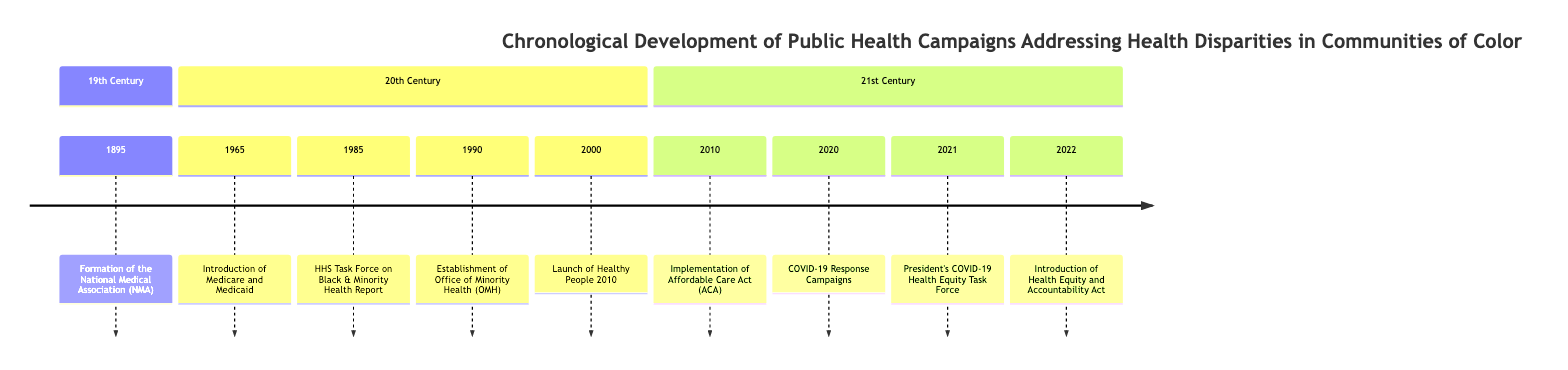What event occurred in 1895? The timeline shows that in 1895, the formation of the National Medical Association (NMA) took place, aimed at addressing health disparities in African American communities.
Answer: National Medical Association How many key events are listed in the 20th Century section of the timeline? By counting the nodes labeled under the 20th Century section, there are four key events: Introduction of Medicare and Medicaid in 1965, HHS Task Force on Black & Minority Health Report in 1985, Establishment of Office of Minority Health in 1990, and Launch of Healthy People 2010 in 2000.
Answer: 4 What significant legislative act was implemented in 2010? According to the timeline elements, the implementation of the Affordable Care Act (ACA) occurred in 2010.
Answer: Affordable Care Act Which event directly addresses health disparities related to COVID-19? The timeline indicates that the public health campaigns for COVID-19 response in 2020 explicitly targeted the disproportionate impact on communities of color, thus addressing health disparities.
Answer: COVID-19 Response What was the name of the task force formed in 2021? The diagram specifies that the task force formed in 2021 is named the President's COVID-19 Health Equity Task Force.
Answer: President's COVID-19 Health Equity Task Force What was the main focus of the 1985 report by the HHS Task Force? The timeline’s description states that the 1985 report focused on Black & Minority Health, highlighting issues concerning health disparities in these communities.
Answer: Black & Minority Health What is the primary goal of the Office of Minority Health established in 1990? The timeline notes that the Office of Minority Health (OMH) was established to improve the health of racial and ethnic minority populations, indicating its primary goal.
Answer: Improve health What year did the Healthy People initiative begin focusing on health disparities? The timeline shows that Healthy People 2010 was launched in the year 2000, marking the initiative's focus on reducing health disparities.
Answer: 2000 What does the Health Equity and Accountability Act aim to address? The timeline states that the Health Equity and Accountability Act introduced in 2022 aims to improve health outcomes for underserved communities, indicating its purpose within the timeline.
Answer: Health outcomes 